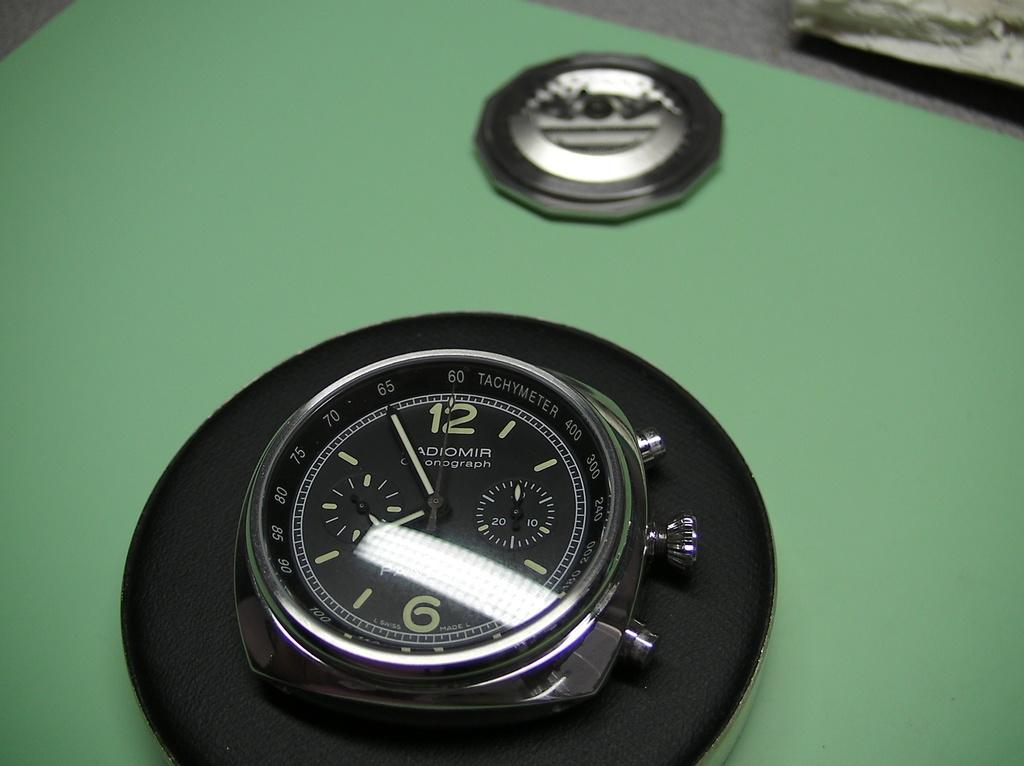<image>
Offer a succinct explanation of the picture presented. An Adiomir Chronograph Tachmeter shows numbers from 400 down to 60. 